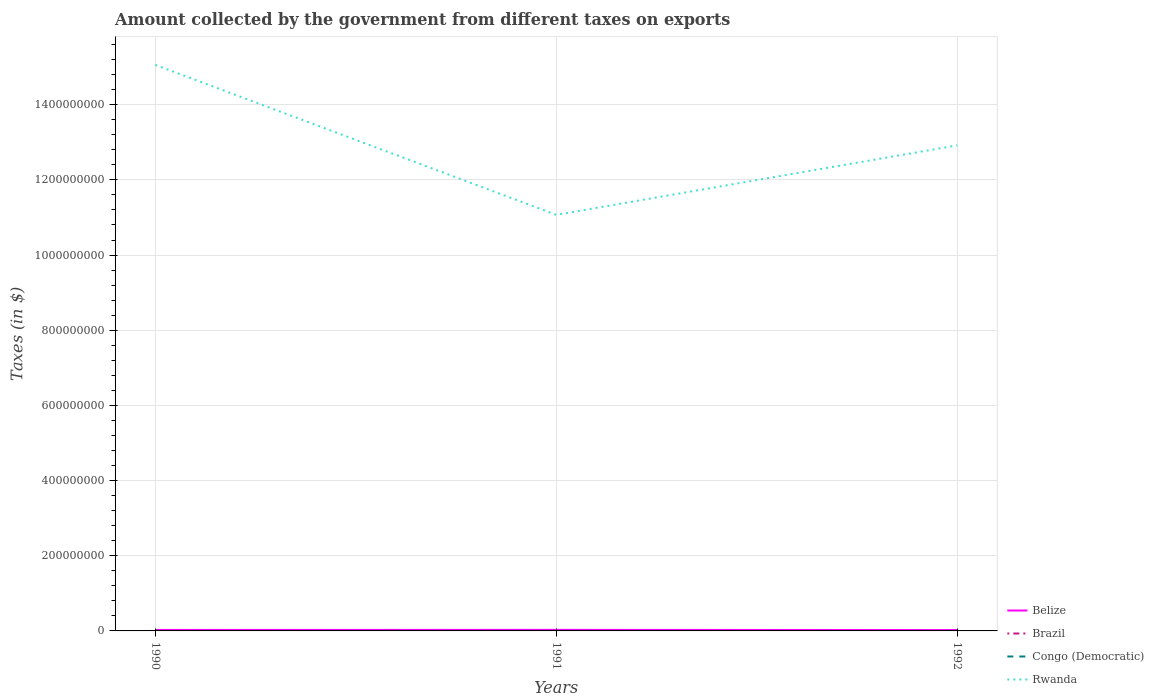How many different coloured lines are there?
Give a very brief answer. 4. Is the number of lines equal to the number of legend labels?
Your answer should be very brief. Yes. Across all years, what is the maximum amount collected by the government from taxes on exports in Congo (Democratic)?
Your answer should be compact. 0.09. What is the total amount collected by the government from taxes on exports in Rwanda in the graph?
Ensure brevity in your answer.  3.99e+08. What is the difference between the highest and the second highest amount collected by the government from taxes on exports in Belize?
Provide a short and direct response. 5.07e+05. What is the difference between the highest and the lowest amount collected by the government from taxes on exports in Congo (Democratic)?
Offer a terse response. 1. Is the amount collected by the government from taxes on exports in Belize strictly greater than the amount collected by the government from taxes on exports in Rwanda over the years?
Your response must be concise. Yes. How many lines are there?
Keep it short and to the point. 4. What is the difference between two consecutive major ticks on the Y-axis?
Provide a short and direct response. 2.00e+08. What is the title of the graph?
Make the answer very short. Amount collected by the government from different taxes on exports. What is the label or title of the Y-axis?
Offer a terse response. Taxes (in $). What is the Taxes (in $) of Belize in 1990?
Offer a terse response. 2.60e+06. What is the Taxes (in $) of Brazil in 1990?
Your answer should be compact. 1018.18. What is the Taxes (in $) of Congo (Democratic) in 1990?
Provide a short and direct response. 0.09. What is the Taxes (in $) in Rwanda in 1990?
Your answer should be very brief. 1.51e+09. What is the Taxes (in $) of Belize in 1991?
Your answer should be very brief. 2.84e+06. What is the Taxes (in $) of Brazil in 1991?
Your answer should be very brief. 1527.27. What is the Taxes (in $) in Congo (Democratic) in 1991?
Your answer should be very brief. 0.98. What is the Taxes (in $) of Rwanda in 1991?
Give a very brief answer. 1.11e+09. What is the Taxes (in $) of Belize in 1992?
Offer a terse response. 2.34e+06. What is the Taxes (in $) in Brazil in 1992?
Your answer should be very brief. 1200. What is the Taxes (in $) in Congo (Democratic) in 1992?
Offer a very short reply. 34.5. What is the Taxes (in $) of Rwanda in 1992?
Make the answer very short. 1.29e+09. Across all years, what is the maximum Taxes (in $) of Belize?
Keep it short and to the point. 2.84e+06. Across all years, what is the maximum Taxes (in $) of Brazil?
Offer a very short reply. 1527.27. Across all years, what is the maximum Taxes (in $) in Congo (Democratic)?
Provide a short and direct response. 34.5. Across all years, what is the maximum Taxes (in $) in Rwanda?
Offer a terse response. 1.51e+09. Across all years, what is the minimum Taxes (in $) of Belize?
Your answer should be compact. 2.34e+06. Across all years, what is the minimum Taxes (in $) of Brazil?
Make the answer very short. 1018.18. Across all years, what is the minimum Taxes (in $) in Congo (Democratic)?
Make the answer very short. 0.09. Across all years, what is the minimum Taxes (in $) of Rwanda?
Provide a short and direct response. 1.11e+09. What is the total Taxes (in $) in Belize in the graph?
Your response must be concise. 7.78e+06. What is the total Taxes (in $) of Brazil in the graph?
Your answer should be compact. 3745.45. What is the total Taxes (in $) of Congo (Democratic) in the graph?
Ensure brevity in your answer.  35.56. What is the total Taxes (in $) of Rwanda in the graph?
Your answer should be compact. 3.90e+09. What is the difference between the Taxes (in $) of Belize in 1990 and that in 1991?
Ensure brevity in your answer.  -2.42e+05. What is the difference between the Taxes (in $) in Brazil in 1990 and that in 1991?
Give a very brief answer. -509.09. What is the difference between the Taxes (in $) in Congo (Democratic) in 1990 and that in 1991?
Offer a terse response. -0.89. What is the difference between the Taxes (in $) of Rwanda in 1990 and that in 1991?
Your answer should be compact. 3.99e+08. What is the difference between the Taxes (in $) of Belize in 1990 and that in 1992?
Give a very brief answer. 2.65e+05. What is the difference between the Taxes (in $) in Brazil in 1990 and that in 1992?
Provide a short and direct response. -181.82. What is the difference between the Taxes (in $) in Congo (Democratic) in 1990 and that in 1992?
Give a very brief answer. -34.41. What is the difference between the Taxes (in $) of Rwanda in 1990 and that in 1992?
Your answer should be very brief. 2.14e+08. What is the difference between the Taxes (in $) in Belize in 1991 and that in 1992?
Your answer should be very brief. 5.07e+05. What is the difference between the Taxes (in $) in Brazil in 1991 and that in 1992?
Keep it short and to the point. 327.27. What is the difference between the Taxes (in $) in Congo (Democratic) in 1991 and that in 1992?
Offer a terse response. -33.52. What is the difference between the Taxes (in $) of Rwanda in 1991 and that in 1992?
Provide a short and direct response. -1.85e+08. What is the difference between the Taxes (in $) in Belize in 1990 and the Taxes (in $) in Brazil in 1991?
Keep it short and to the point. 2.60e+06. What is the difference between the Taxes (in $) of Belize in 1990 and the Taxes (in $) of Congo (Democratic) in 1991?
Offer a very short reply. 2.60e+06. What is the difference between the Taxes (in $) in Belize in 1990 and the Taxes (in $) in Rwanda in 1991?
Provide a succinct answer. -1.10e+09. What is the difference between the Taxes (in $) in Brazil in 1990 and the Taxes (in $) in Congo (Democratic) in 1991?
Your answer should be very brief. 1017.21. What is the difference between the Taxes (in $) in Brazil in 1990 and the Taxes (in $) in Rwanda in 1991?
Your response must be concise. -1.11e+09. What is the difference between the Taxes (in $) of Congo (Democratic) in 1990 and the Taxes (in $) of Rwanda in 1991?
Your answer should be compact. -1.11e+09. What is the difference between the Taxes (in $) in Belize in 1990 and the Taxes (in $) in Brazil in 1992?
Your response must be concise. 2.60e+06. What is the difference between the Taxes (in $) in Belize in 1990 and the Taxes (in $) in Congo (Democratic) in 1992?
Your response must be concise. 2.60e+06. What is the difference between the Taxes (in $) in Belize in 1990 and the Taxes (in $) in Rwanda in 1992?
Ensure brevity in your answer.  -1.29e+09. What is the difference between the Taxes (in $) in Brazil in 1990 and the Taxes (in $) in Congo (Democratic) in 1992?
Keep it short and to the point. 983.68. What is the difference between the Taxes (in $) of Brazil in 1990 and the Taxes (in $) of Rwanda in 1992?
Make the answer very short. -1.29e+09. What is the difference between the Taxes (in $) in Congo (Democratic) in 1990 and the Taxes (in $) in Rwanda in 1992?
Keep it short and to the point. -1.29e+09. What is the difference between the Taxes (in $) of Belize in 1991 and the Taxes (in $) of Brazil in 1992?
Offer a very short reply. 2.84e+06. What is the difference between the Taxes (in $) of Belize in 1991 and the Taxes (in $) of Congo (Democratic) in 1992?
Provide a succinct answer. 2.84e+06. What is the difference between the Taxes (in $) of Belize in 1991 and the Taxes (in $) of Rwanda in 1992?
Your answer should be very brief. -1.29e+09. What is the difference between the Taxes (in $) in Brazil in 1991 and the Taxes (in $) in Congo (Democratic) in 1992?
Your answer should be very brief. 1492.77. What is the difference between the Taxes (in $) of Brazil in 1991 and the Taxes (in $) of Rwanda in 1992?
Make the answer very short. -1.29e+09. What is the difference between the Taxes (in $) in Congo (Democratic) in 1991 and the Taxes (in $) in Rwanda in 1992?
Keep it short and to the point. -1.29e+09. What is the average Taxes (in $) in Belize per year?
Your response must be concise. 2.59e+06. What is the average Taxes (in $) in Brazil per year?
Your answer should be compact. 1248.48. What is the average Taxes (in $) of Congo (Democratic) per year?
Give a very brief answer. 11.85. What is the average Taxes (in $) of Rwanda per year?
Your answer should be compact. 1.30e+09. In the year 1990, what is the difference between the Taxes (in $) in Belize and Taxes (in $) in Brazil?
Your response must be concise. 2.60e+06. In the year 1990, what is the difference between the Taxes (in $) of Belize and Taxes (in $) of Congo (Democratic)?
Provide a short and direct response. 2.60e+06. In the year 1990, what is the difference between the Taxes (in $) of Belize and Taxes (in $) of Rwanda?
Your answer should be compact. -1.50e+09. In the year 1990, what is the difference between the Taxes (in $) in Brazil and Taxes (in $) in Congo (Democratic)?
Offer a very short reply. 1018.1. In the year 1990, what is the difference between the Taxes (in $) in Brazil and Taxes (in $) in Rwanda?
Your response must be concise. -1.51e+09. In the year 1990, what is the difference between the Taxes (in $) of Congo (Democratic) and Taxes (in $) of Rwanda?
Your answer should be compact. -1.51e+09. In the year 1991, what is the difference between the Taxes (in $) of Belize and Taxes (in $) of Brazil?
Ensure brevity in your answer.  2.84e+06. In the year 1991, what is the difference between the Taxes (in $) of Belize and Taxes (in $) of Congo (Democratic)?
Your response must be concise. 2.84e+06. In the year 1991, what is the difference between the Taxes (in $) of Belize and Taxes (in $) of Rwanda?
Keep it short and to the point. -1.10e+09. In the year 1991, what is the difference between the Taxes (in $) of Brazil and Taxes (in $) of Congo (Democratic)?
Your response must be concise. 1526.3. In the year 1991, what is the difference between the Taxes (in $) of Brazil and Taxes (in $) of Rwanda?
Your answer should be compact. -1.11e+09. In the year 1991, what is the difference between the Taxes (in $) of Congo (Democratic) and Taxes (in $) of Rwanda?
Your answer should be very brief. -1.11e+09. In the year 1992, what is the difference between the Taxes (in $) of Belize and Taxes (in $) of Brazil?
Offer a terse response. 2.33e+06. In the year 1992, what is the difference between the Taxes (in $) of Belize and Taxes (in $) of Congo (Democratic)?
Provide a succinct answer. 2.34e+06. In the year 1992, what is the difference between the Taxes (in $) in Belize and Taxes (in $) in Rwanda?
Ensure brevity in your answer.  -1.29e+09. In the year 1992, what is the difference between the Taxes (in $) in Brazil and Taxes (in $) in Congo (Democratic)?
Give a very brief answer. 1165.5. In the year 1992, what is the difference between the Taxes (in $) in Brazil and Taxes (in $) in Rwanda?
Offer a very short reply. -1.29e+09. In the year 1992, what is the difference between the Taxes (in $) in Congo (Democratic) and Taxes (in $) in Rwanda?
Ensure brevity in your answer.  -1.29e+09. What is the ratio of the Taxes (in $) in Belize in 1990 to that in 1991?
Your answer should be compact. 0.91. What is the ratio of the Taxes (in $) in Brazil in 1990 to that in 1991?
Your answer should be compact. 0.67. What is the ratio of the Taxes (in $) in Congo (Democratic) in 1990 to that in 1991?
Give a very brief answer. 0.09. What is the ratio of the Taxes (in $) of Rwanda in 1990 to that in 1991?
Make the answer very short. 1.36. What is the ratio of the Taxes (in $) in Belize in 1990 to that in 1992?
Ensure brevity in your answer.  1.11. What is the ratio of the Taxes (in $) of Brazil in 1990 to that in 1992?
Make the answer very short. 0.85. What is the ratio of the Taxes (in $) of Congo (Democratic) in 1990 to that in 1992?
Ensure brevity in your answer.  0. What is the ratio of the Taxes (in $) of Rwanda in 1990 to that in 1992?
Offer a very short reply. 1.17. What is the ratio of the Taxes (in $) of Belize in 1991 to that in 1992?
Offer a very short reply. 1.22. What is the ratio of the Taxes (in $) in Brazil in 1991 to that in 1992?
Offer a terse response. 1.27. What is the ratio of the Taxes (in $) in Congo (Democratic) in 1991 to that in 1992?
Make the answer very short. 0.03. What is the ratio of the Taxes (in $) of Rwanda in 1991 to that in 1992?
Your answer should be compact. 0.86. What is the difference between the highest and the second highest Taxes (in $) in Belize?
Your response must be concise. 2.42e+05. What is the difference between the highest and the second highest Taxes (in $) in Brazil?
Provide a succinct answer. 327.27. What is the difference between the highest and the second highest Taxes (in $) in Congo (Democratic)?
Offer a very short reply. 33.52. What is the difference between the highest and the second highest Taxes (in $) of Rwanda?
Offer a very short reply. 2.14e+08. What is the difference between the highest and the lowest Taxes (in $) in Belize?
Ensure brevity in your answer.  5.07e+05. What is the difference between the highest and the lowest Taxes (in $) of Brazil?
Ensure brevity in your answer.  509.09. What is the difference between the highest and the lowest Taxes (in $) of Congo (Democratic)?
Provide a short and direct response. 34.41. What is the difference between the highest and the lowest Taxes (in $) of Rwanda?
Your answer should be very brief. 3.99e+08. 